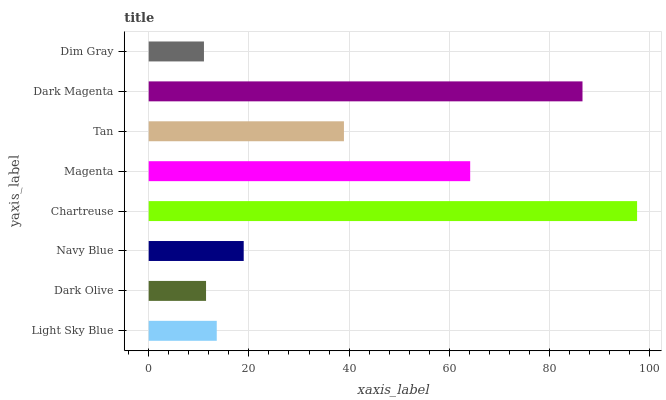Is Dim Gray the minimum?
Answer yes or no. Yes. Is Chartreuse the maximum?
Answer yes or no. Yes. Is Dark Olive the minimum?
Answer yes or no. No. Is Dark Olive the maximum?
Answer yes or no. No. Is Light Sky Blue greater than Dark Olive?
Answer yes or no. Yes. Is Dark Olive less than Light Sky Blue?
Answer yes or no. Yes. Is Dark Olive greater than Light Sky Blue?
Answer yes or no. No. Is Light Sky Blue less than Dark Olive?
Answer yes or no. No. Is Tan the high median?
Answer yes or no. Yes. Is Navy Blue the low median?
Answer yes or no. Yes. Is Magenta the high median?
Answer yes or no. No. Is Light Sky Blue the low median?
Answer yes or no. No. 